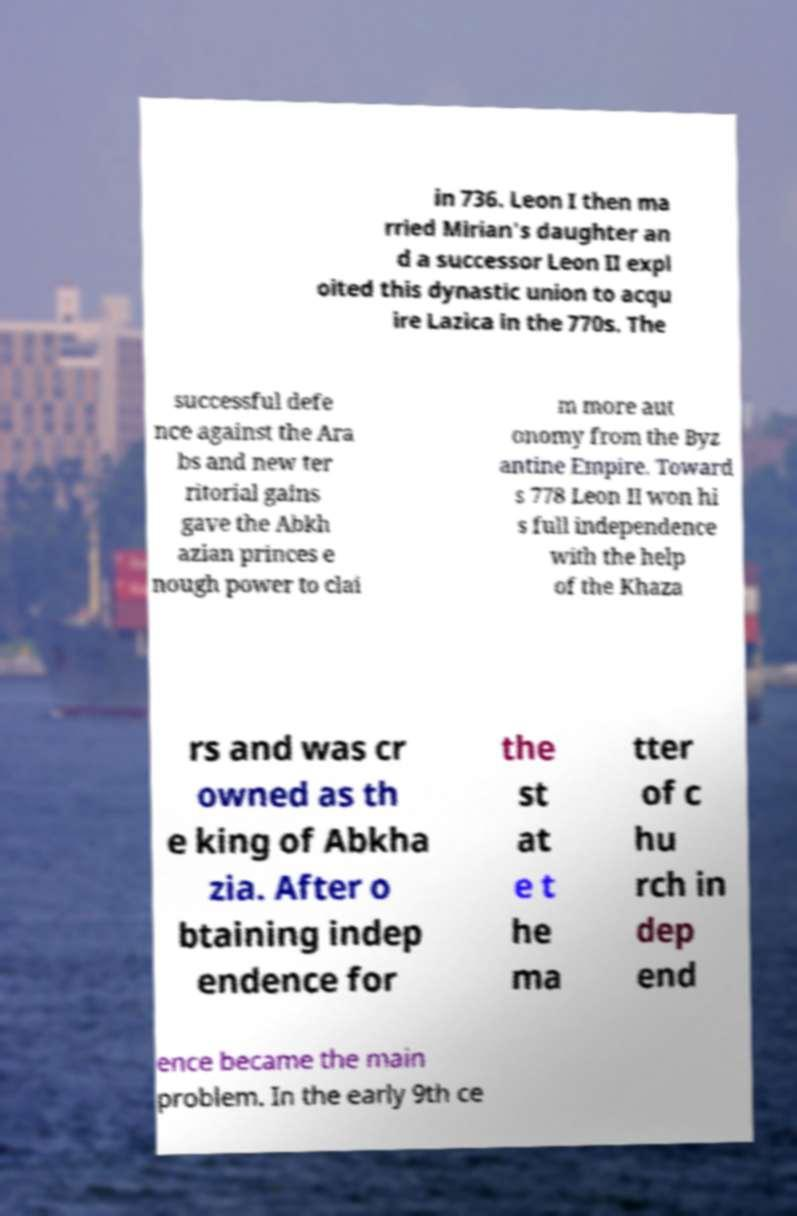For documentation purposes, I need the text within this image transcribed. Could you provide that? in 736. Leon I then ma rried Mirian's daughter an d a successor Leon II expl oited this dynastic union to acqu ire Lazica in the 770s. The successful defe nce against the Ara bs and new ter ritorial gains gave the Abkh azian princes e nough power to clai m more aut onomy from the Byz antine Empire. Toward s 778 Leon II won hi s full independence with the help of the Khaza rs and was cr owned as th e king of Abkha zia. After o btaining indep endence for the st at e t he ma tter of c hu rch in dep end ence became the main problem. In the early 9th ce 